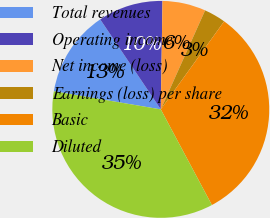<chart> <loc_0><loc_0><loc_500><loc_500><pie_chart><fcel>Total revenues<fcel>Operating income<fcel>Net income (loss)<fcel>Earnings (loss) per share<fcel>Basic<fcel>Diluted<nl><fcel>12.9%<fcel>9.68%<fcel>6.45%<fcel>3.23%<fcel>32.26%<fcel>35.48%<nl></chart> 